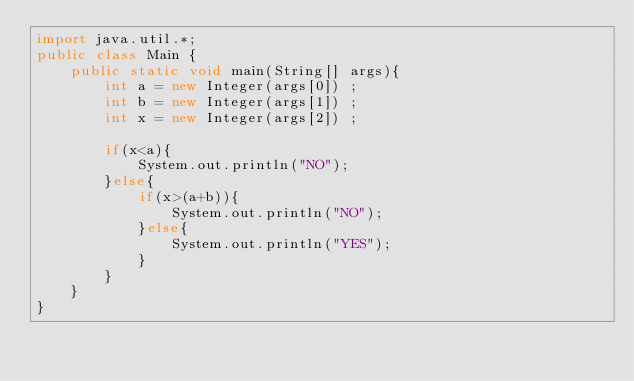<code> <loc_0><loc_0><loc_500><loc_500><_Java_>import java.util.*;
public class Main {
	public static void main(String[] args){
		int a = new Integer(args[0]) ;
		int b = new Integer(args[1]) ;
		int x = new Integer(args[2]) ;
		
		if(x<a){
			System.out.println("NO");
		}else{
			if(x>(a+b)){
				System.out.println("NO");
			}else{
				System.out.println("YES");
			}
		}
	}
}
</code> 